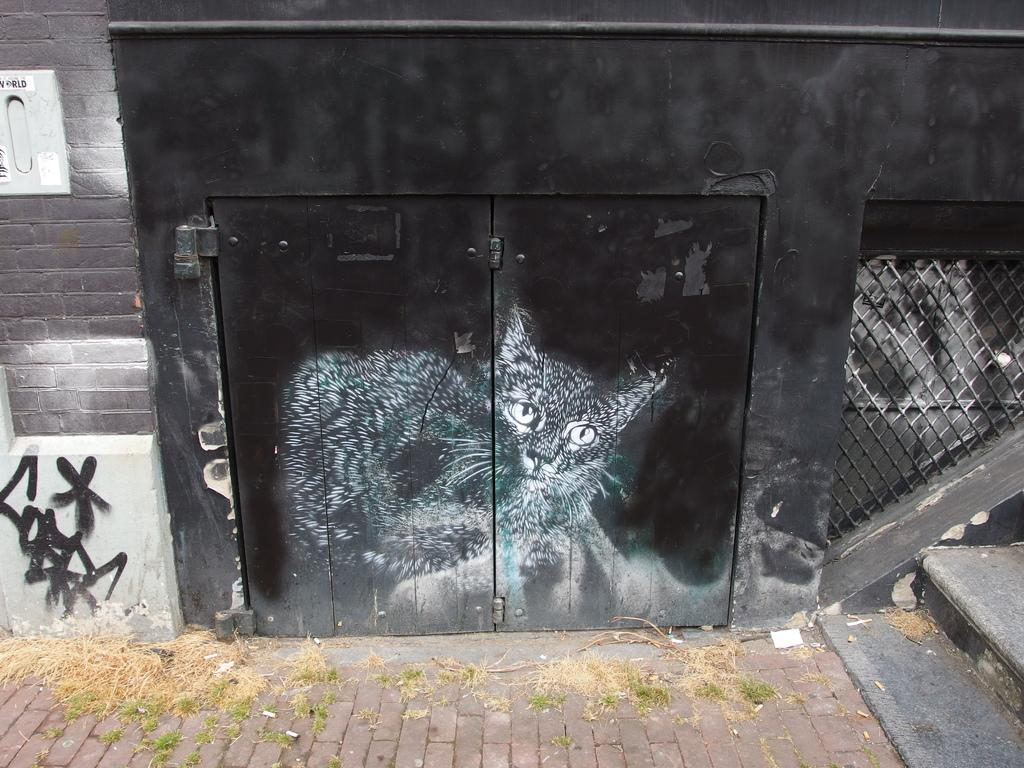What type of surface is covering the road in the image? There is grass on the road in the image. What architectural feature can be seen in the image? There are steps in the image. What is depicted on the gate in the image? There is a cat picture on a black color gate in the image. What color is the wall in the image? There is a black color wall in the image. What type of wall is visible in the image? There is a brick wall in the image. What type of vest is the cat wearing in the image? There is no cat wearing a vest in the image; it is a picture of a cat on a gate. How many bags of popcorn are visible in the image? There are no bags of popcorn present in the image. 